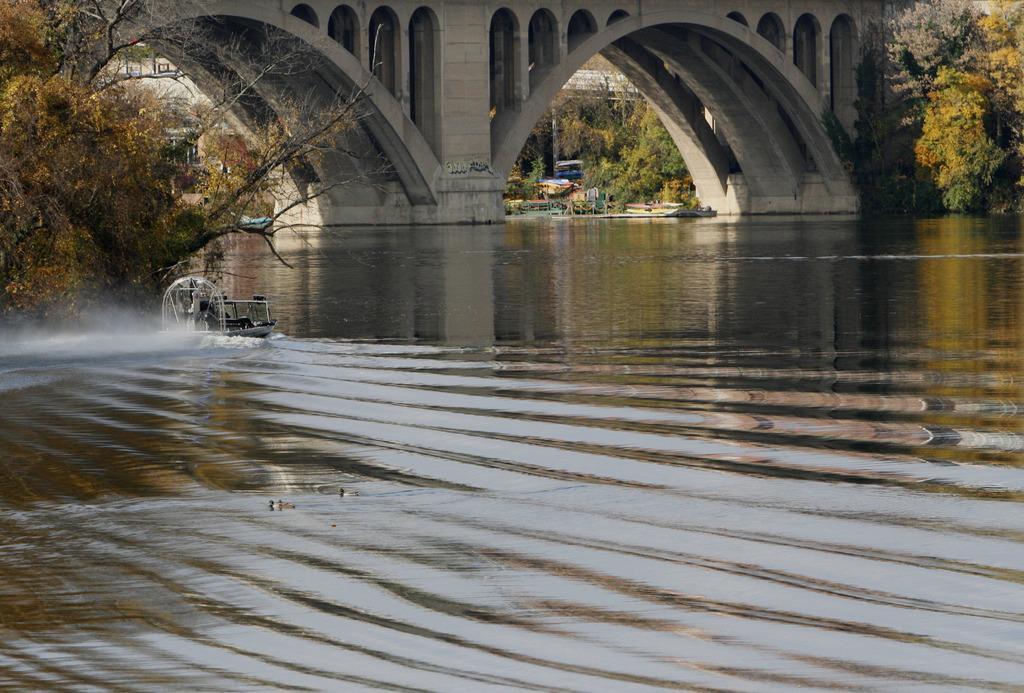Can you describe this image briefly? This image consists of a bridge at the top. There are trees at the top. There is the boat on the left side. There is water in the middle. 